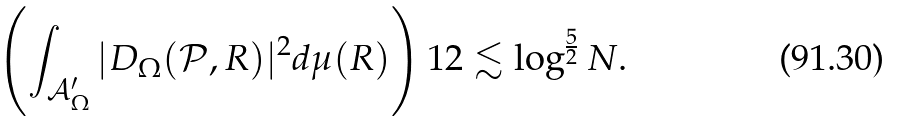Convert formula to latex. <formula><loc_0><loc_0><loc_500><loc_500>\left ( \int _ { { \mathcal { A } } ^ { \prime } _ { \Omega } } | D _ { \Omega } ( { \mathcal { P } } , R ) | ^ { 2 } d \mu ( R ) \right ) ^ { } { 1 } 2 \lesssim \log ^ { \frac { 5 } { 2 } } N .</formula> 